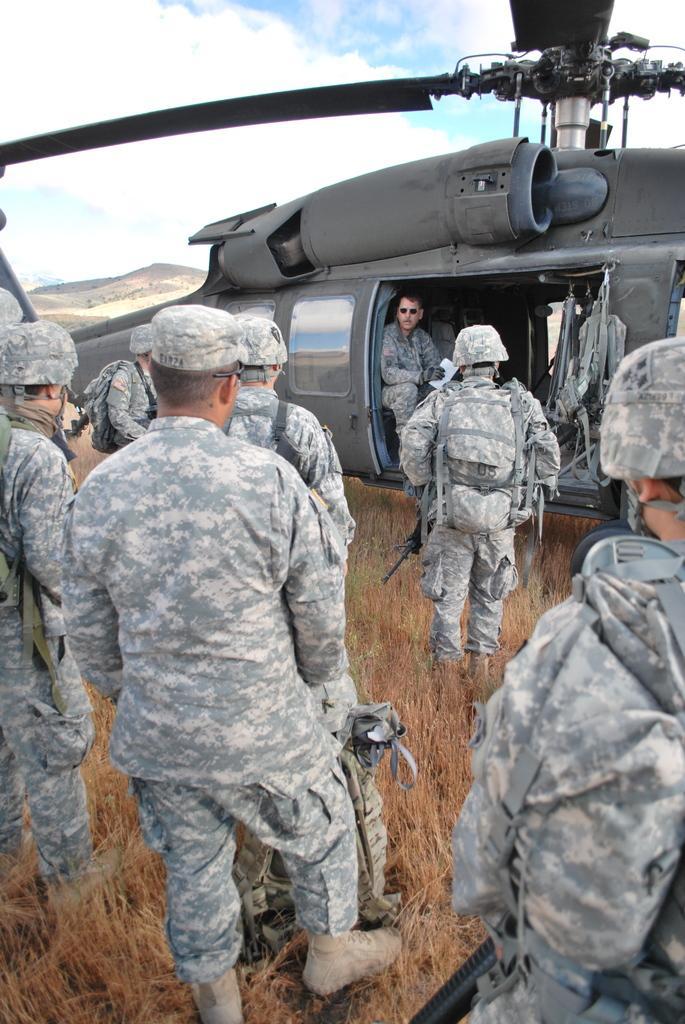In one or two sentences, can you explain what this image depicts? As we can see in the image there are few people wearing army dress and a plane. There is grass. On the top there is sky and clouds. 